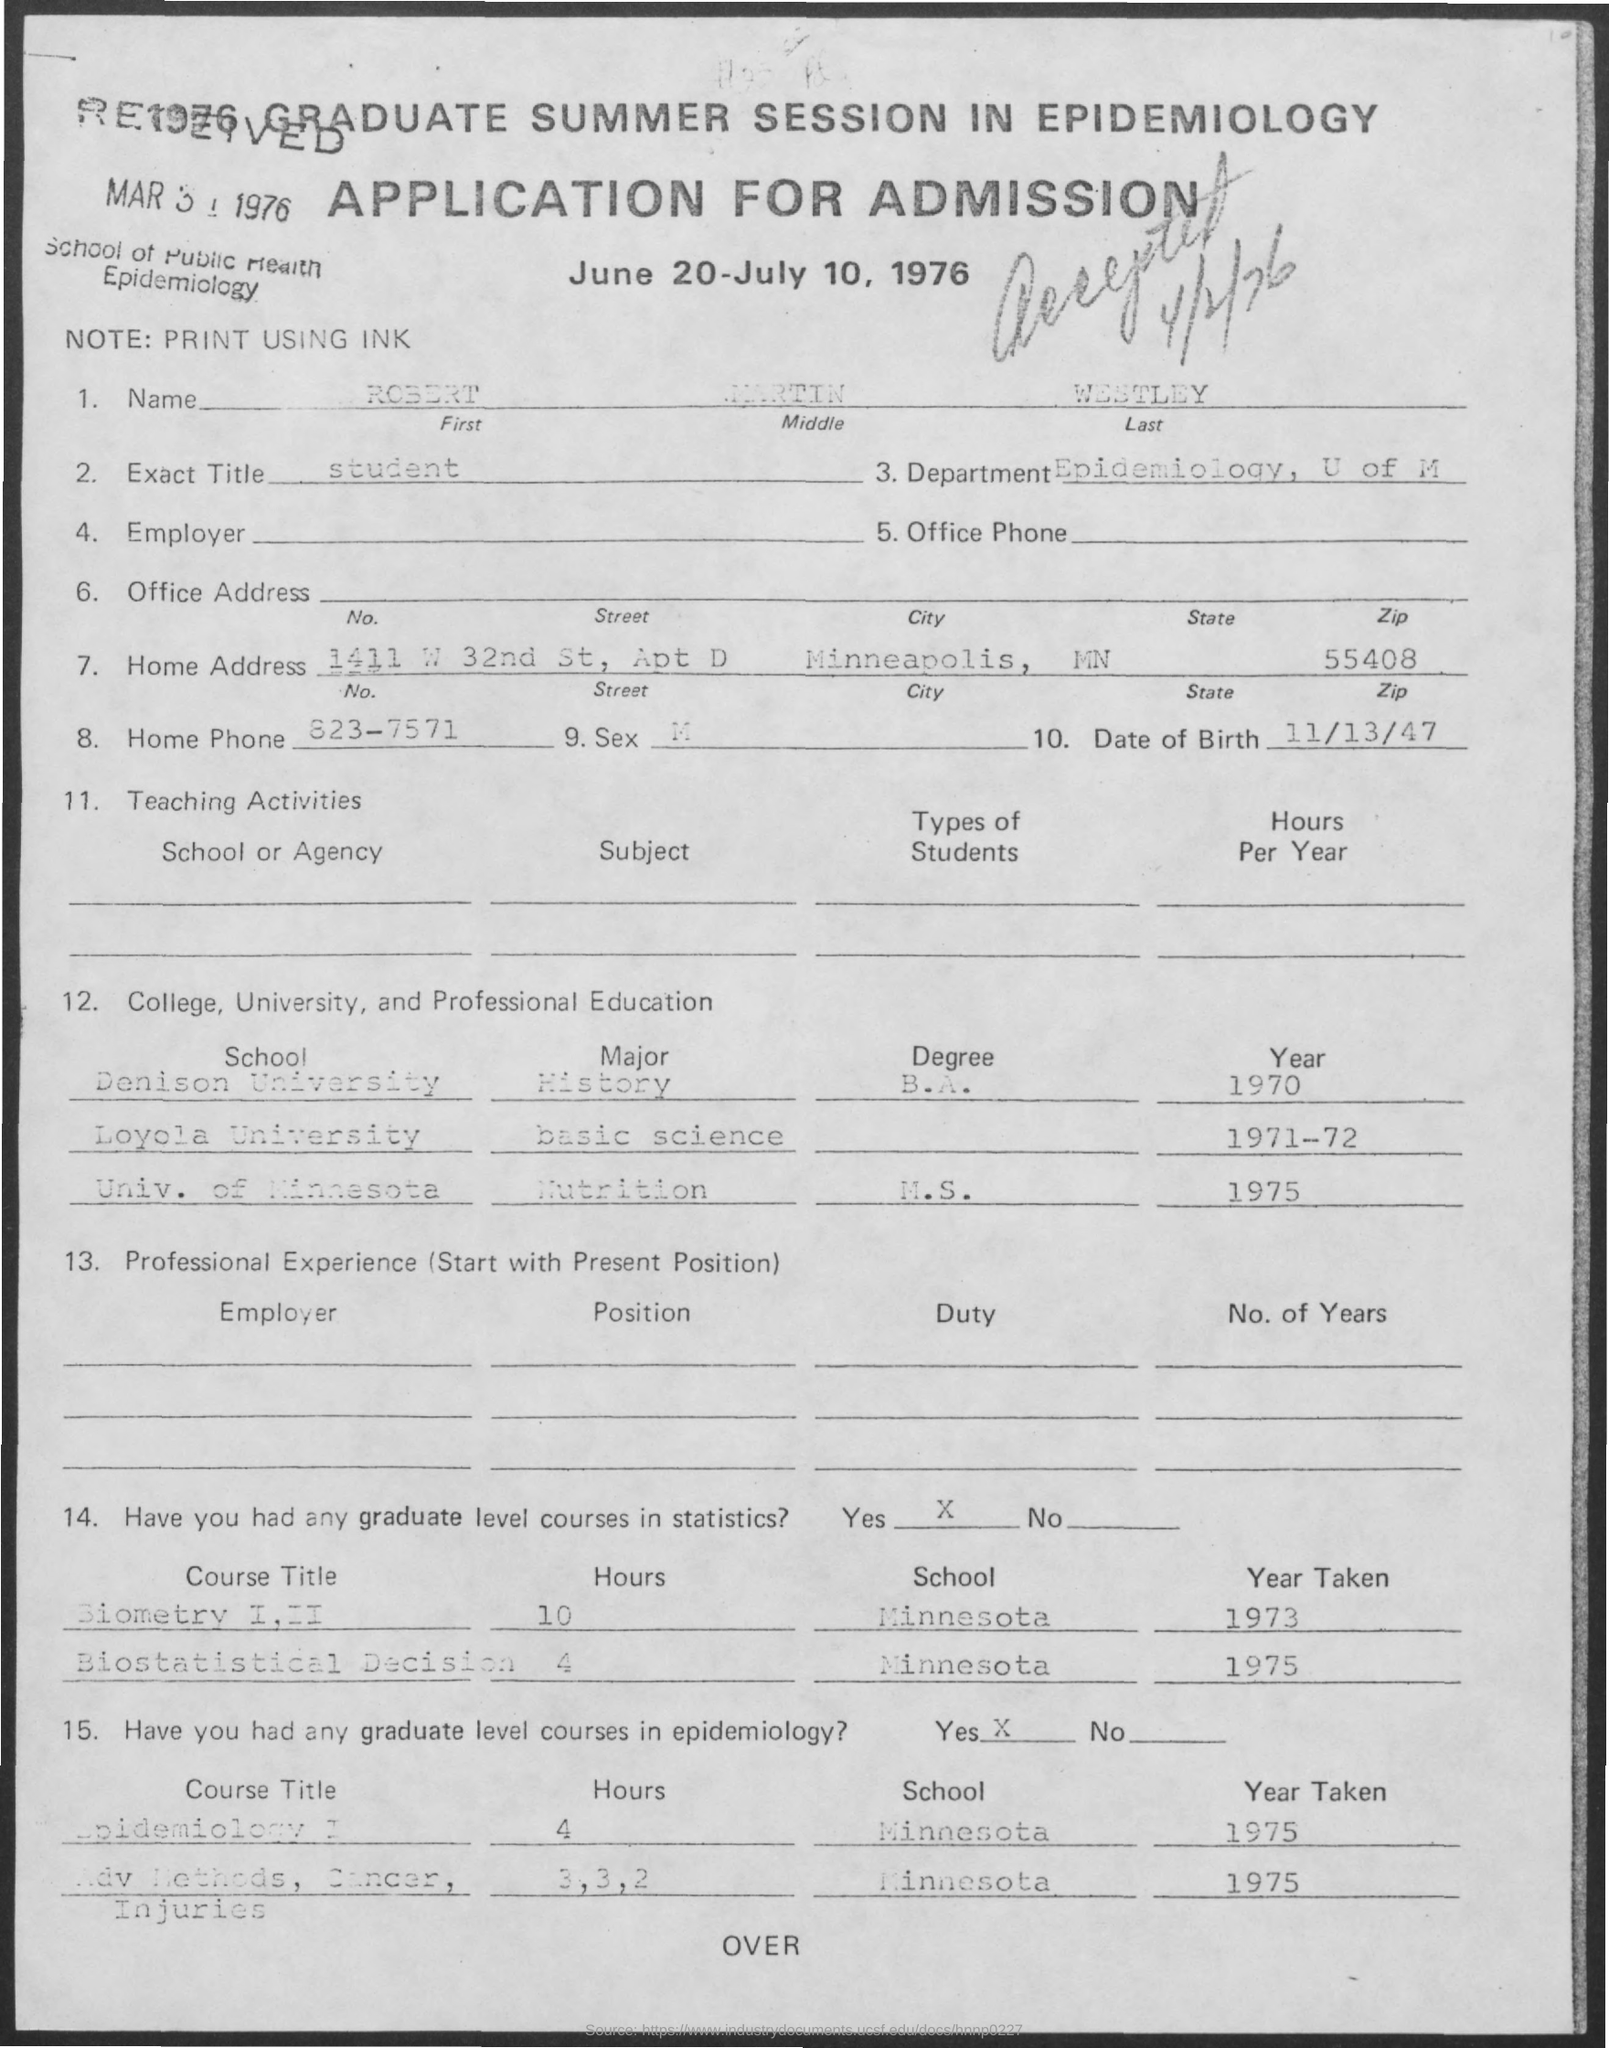What are the dates of the session mentioned in this application? The session dates mentioned in the document are from June 20 to July 10, 1976. 